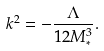<formula> <loc_0><loc_0><loc_500><loc_500>k ^ { 2 } = - \frac { \Lambda } { 1 2 M _ { * } ^ { 3 } } .</formula> 